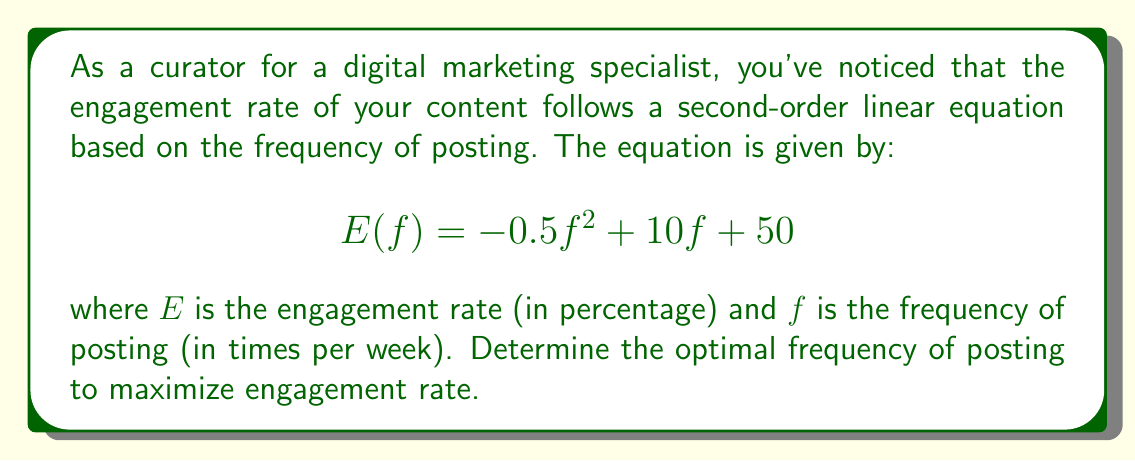Give your solution to this math problem. To find the optimal frequency of posting that maximizes the engagement rate, we need to find the maximum point of the quadratic function $E(f)$. This can be done by following these steps:

1. The general form of a quadratic function is $ax^2 + bx + c$, where $a$, $b$, and $c$ are constants and $a \neq 0$. In our case:
   $a = -0.5$, $b = 10$, and $c = 50$

2. For a quadratic function, the x-coordinate of the vertex (which represents the optimal point) is given by the formula:

   $$f = -\frac{b}{2a}$$

3. Substituting our values:

   $$f = -\frac{10}{2(-0.5)} = -\frac{10}{-1} = 10$$

4. To verify this is a maximum (not a minimum), we can check that $a < 0$, which is true in this case $(a = -0.5)$.

5. The optimal frequency is therefore 10 times per week.

6. To find the maximum engagement rate, we substitute $f = 10$ into the original equation:

   $$E(10) = -0.5(10)^2 + 10(10) + 50$$
   $$= -0.5(100) + 100 + 50$$
   $$= -50 + 100 + 50$$
   $$= 100$$

Therefore, the maximum engagement rate is 100%.
Answer: The optimal frequency of posting is 10 times per week, which results in a maximum engagement rate of 100%. 